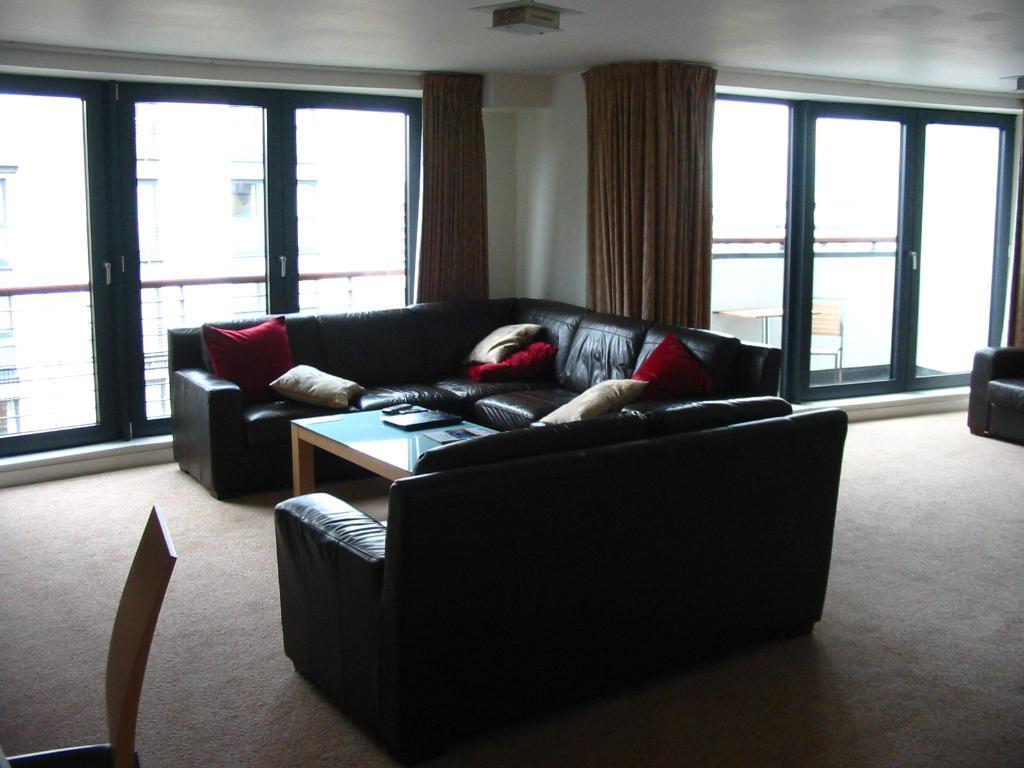In one or two sentences, can you explain what this image depicts? In a room there is a sofa with pillows on it. In front of the sofa there is a table with laptop on it. In the background there is a door with curtains. 